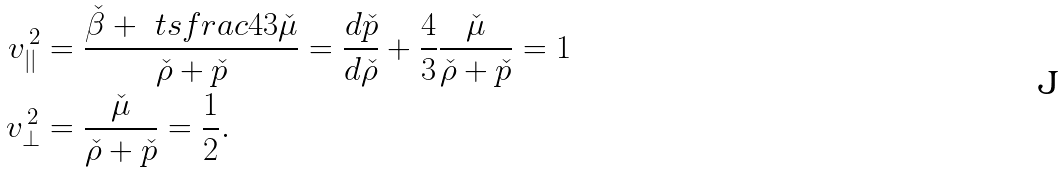Convert formula to latex. <formula><loc_0><loc_0><loc_500><loc_500>v _ { | | } ^ { \, 2 } & = \frac { \check { \beta } + \ t s f r a c 4 3 \check { \mu } } { \check { \rho } + \check { p } } = \frac { d \check { p } } { d \check { \rho } } + \frac { 4 } { 3 } \frac { \check { \mu } } { \check { \rho } + \check { p } } = 1 \\ v _ { \perp } ^ { \, 2 } & = \frac { \check { \mu } } { \check { \rho } + \check { p } } = \frac { 1 } { 2 } .</formula> 